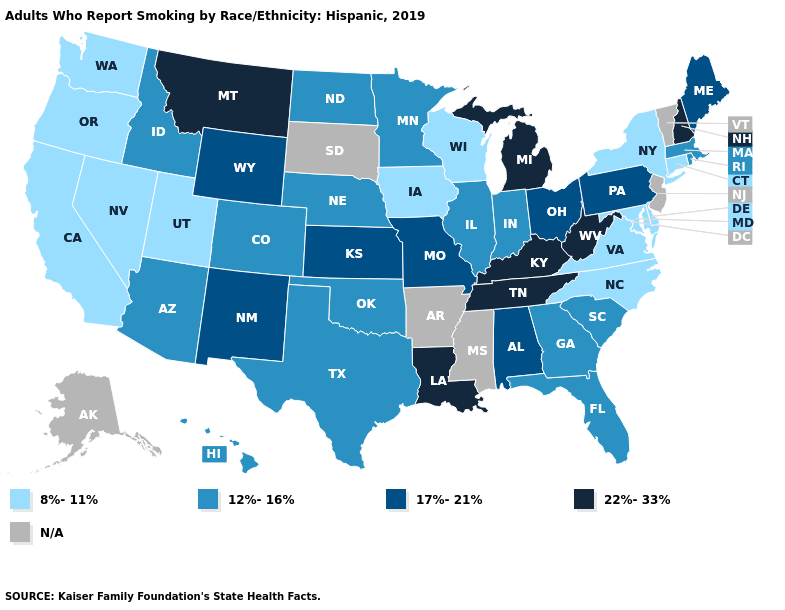What is the value of Pennsylvania?
Answer briefly. 17%-21%. Name the states that have a value in the range 12%-16%?
Short answer required. Arizona, Colorado, Florida, Georgia, Hawaii, Idaho, Illinois, Indiana, Massachusetts, Minnesota, Nebraska, North Dakota, Oklahoma, Rhode Island, South Carolina, Texas. Does Tennessee have the highest value in the USA?
Give a very brief answer. Yes. Does Louisiana have the highest value in the USA?
Concise answer only. Yes. Does Tennessee have the lowest value in the USA?
Be succinct. No. How many symbols are there in the legend?
Write a very short answer. 5. Name the states that have a value in the range N/A?
Quick response, please. Alaska, Arkansas, Mississippi, New Jersey, South Dakota, Vermont. Does Delaware have the lowest value in the USA?
Quick response, please. Yes. Which states hav the highest value in the West?
Short answer required. Montana. Name the states that have a value in the range 17%-21%?
Short answer required. Alabama, Kansas, Maine, Missouri, New Mexico, Ohio, Pennsylvania, Wyoming. 